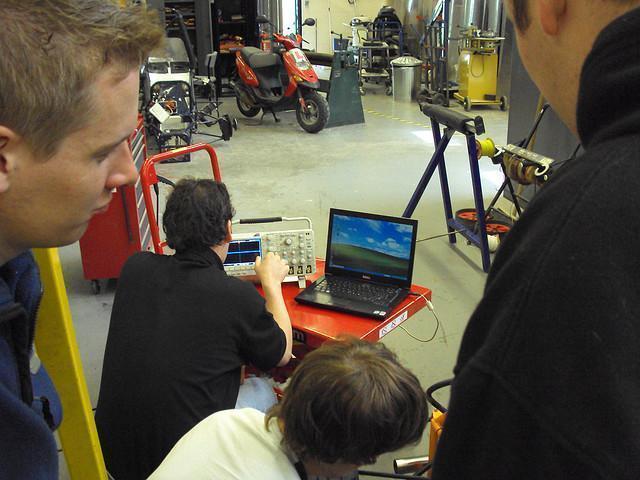What is the man using to control the grey device?
Answer the question by selecting the correct answer among the 4 following choices.
Options: Desktop, phone, laptop, remote. Laptop. 